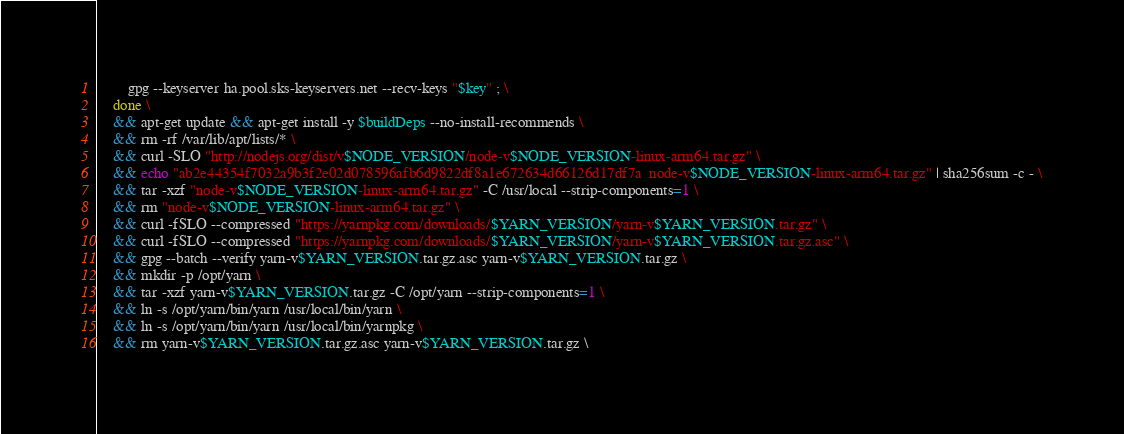Convert code to text. <code><loc_0><loc_0><loc_500><loc_500><_Dockerfile_>		gpg --keyserver ha.pool.sks-keyservers.net --recv-keys "$key" ; \
	done \
	&& apt-get update && apt-get install -y $buildDeps --no-install-recommends \
	&& rm -rf /var/lib/apt/lists/* \
	&& curl -SLO "http://nodejs.org/dist/v$NODE_VERSION/node-v$NODE_VERSION-linux-arm64.tar.gz" \
	&& echo "ab2e44354f7032a9b3f2e02d078596afb6d9822df8a1e672634d66126d17df7a  node-v$NODE_VERSION-linux-arm64.tar.gz" | sha256sum -c - \
	&& tar -xzf "node-v$NODE_VERSION-linux-arm64.tar.gz" -C /usr/local --strip-components=1 \
	&& rm "node-v$NODE_VERSION-linux-arm64.tar.gz" \
	&& curl -fSLO --compressed "https://yarnpkg.com/downloads/$YARN_VERSION/yarn-v$YARN_VERSION.tar.gz" \
	&& curl -fSLO --compressed "https://yarnpkg.com/downloads/$YARN_VERSION/yarn-v$YARN_VERSION.tar.gz.asc" \
	&& gpg --batch --verify yarn-v$YARN_VERSION.tar.gz.asc yarn-v$YARN_VERSION.tar.gz \
	&& mkdir -p /opt/yarn \
	&& tar -xzf yarn-v$YARN_VERSION.tar.gz -C /opt/yarn --strip-components=1 \
	&& ln -s /opt/yarn/bin/yarn /usr/local/bin/yarn \
	&& ln -s /opt/yarn/bin/yarn /usr/local/bin/yarnpkg \
	&& rm yarn-v$YARN_VERSION.tar.gz.asc yarn-v$YARN_VERSION.tar.gz \</code> 